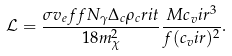Convert formula to latex. <formula><loc_0><loc_0><loc_500><loc_500>\mathcal { L } = \frac { \sigma v _ { e } f f N _ { \gamma } \Delta _ { c } \rho _ { c } r i t } { 1 8 m _ { \chi } ^ { 2 } } \frac { M c _ { v } i r ^ { 3 } } { f ( c _ { v } i r ) ^ { 2 } } .</formula> 